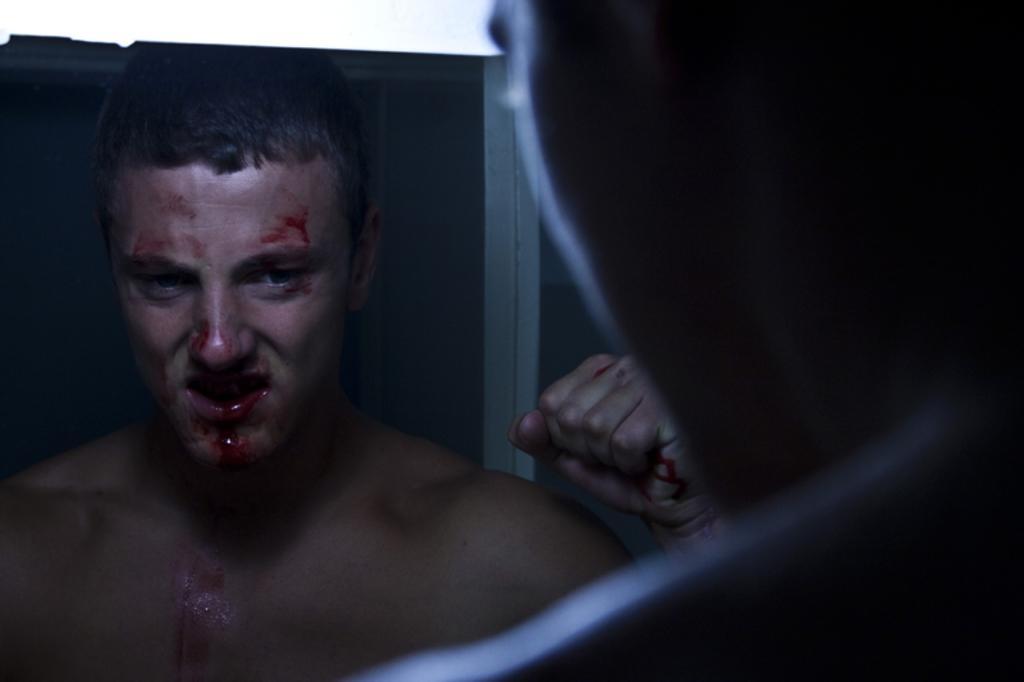Please provide a concise description of this image. In this image we can see a person and his mirror image who is bleeding, and borders are in white color. 